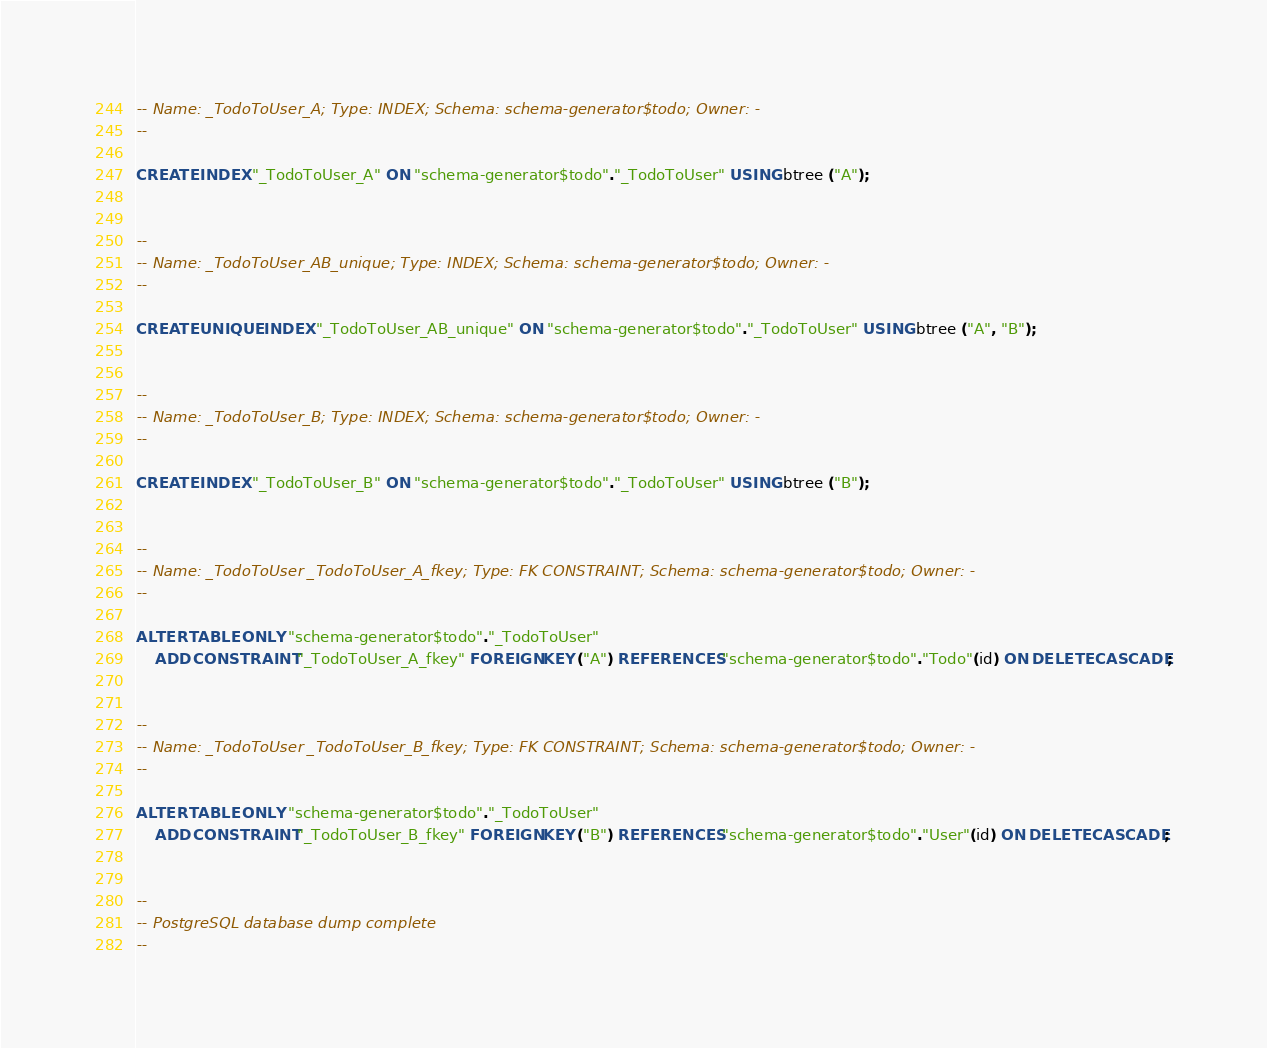Convert code to text. <code><loc_0><loc_0><loc_500><loc_500><_SQL_>-- Name: _TodoToUser_A; Type: INDEX; Schema: schema-generator$todo; Owner: -
--

CREATE INDEX "_TodoToUser_A" ON "schema-generator$todo"."_TodoToUser" USING btree ("A");


--
-- Name: _TodoToUser_AB_unique; Type: INDEX; Schema: schema-generator$todo; Owner: -
--

CREATE UNIQUE INDEX "_TodoToUser_AB_unique" ON "schema-generator$todo"."_TodoToUser" USING btree ("A", "B");


--
-- Name: _TodoToUser_B; Type: INDEX; Schema: schema-generator$todo; Owner: -
--

CREATE INDEX "_TodoToUser_B" ON "schema-generator$todo"."_TodoToUser" USING btree ("B");


--
-- Name: _TodoToUser _TodoToUser_A_fkey; Type: FK CONSTRAINT; Schema: schema-generator$todo; Owner: -
--

ALTER TABLE ONLY "schema-generator$todo"."_TodoToUser"
    ADD CONSTRAINT "_TodoToUser_A_fkey" FOREIGN KEY ("A") REFERENCES "schema-generator$todo"."Todo"(id) ON DELETE CASCADE;


--
-- Name: _TodoToUser _TodoToUser_B_fkey; Type: FK CONSTRAINT; Schema: schema-generator$todo; Owner: -
--

ALTER TABLE ONLY "schema-generator$todo"."_TodoToUser"
    ADD CONSTRAINT "_TodoToUser_B_fkey" FOREIGN KEY ("B") REFERENCES "schema-generator$todo"."User"(id) ON DELETE CASCADE;


--
-- PostgreSQL database dump complete
--

</code> 